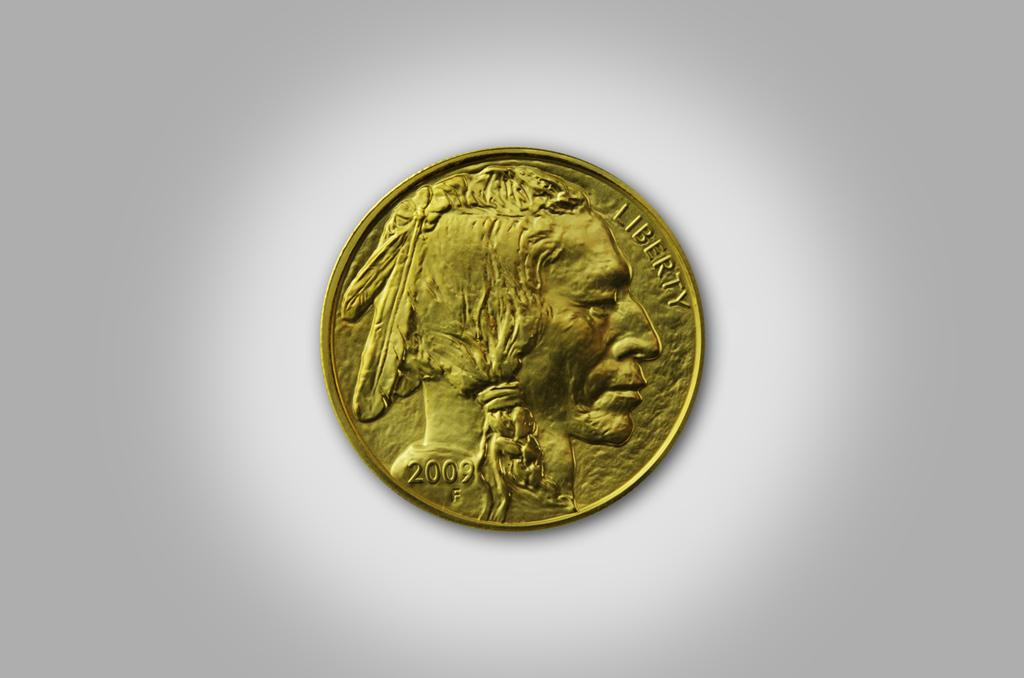What object is the main subject of the image? There is a coin in the image. What is depicted on the coin? The coin has a picture on it. What else can be seen on the coin? The coin has text on it. What color is the background of the image? The background of the image is white. How does the system react to the sneeze in the image? There is no system or sneeze present in the image; it only features a coin with a picture and text on it against a white background. 